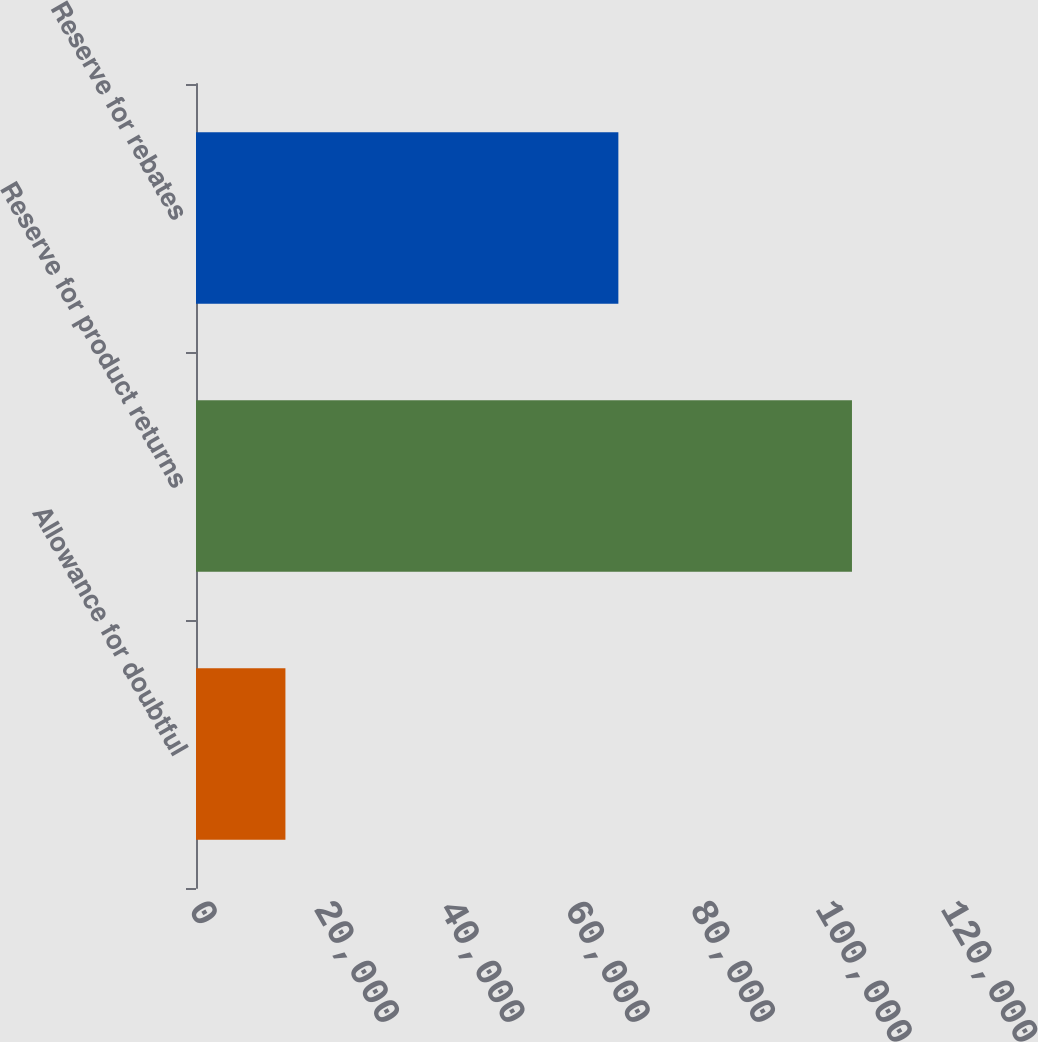<chart> <loc_0><loc_0><loc_500><loc_500><bar_chart><fcel>Allowance for doubtful<fcel>Reserve for product returns<fcel>Reserve for rebates<nl><fcel>14269<fcel>104676<fcel>67399<nl></chart> 